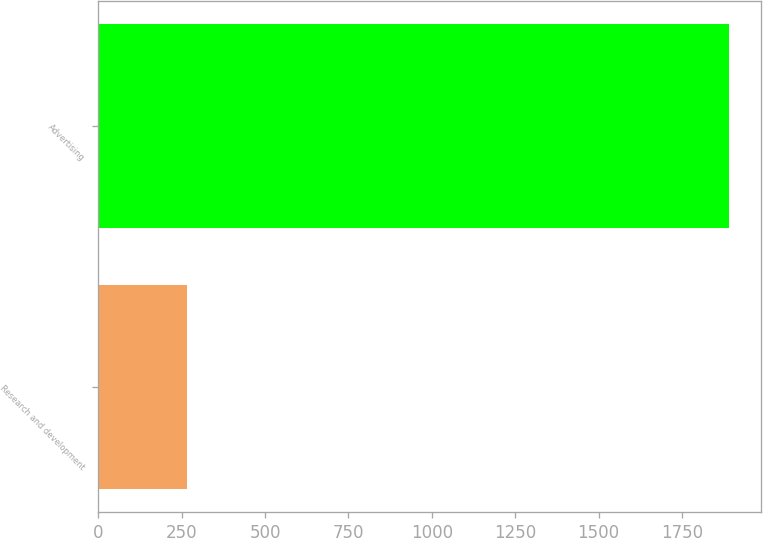Convert chart. <chart><loc_0><loc_0><loc_500><loc_500><bar_chart><fcel>Research and development<fcel>Advertising<nl><fcel>267<fcel>1891<nl></chart> 